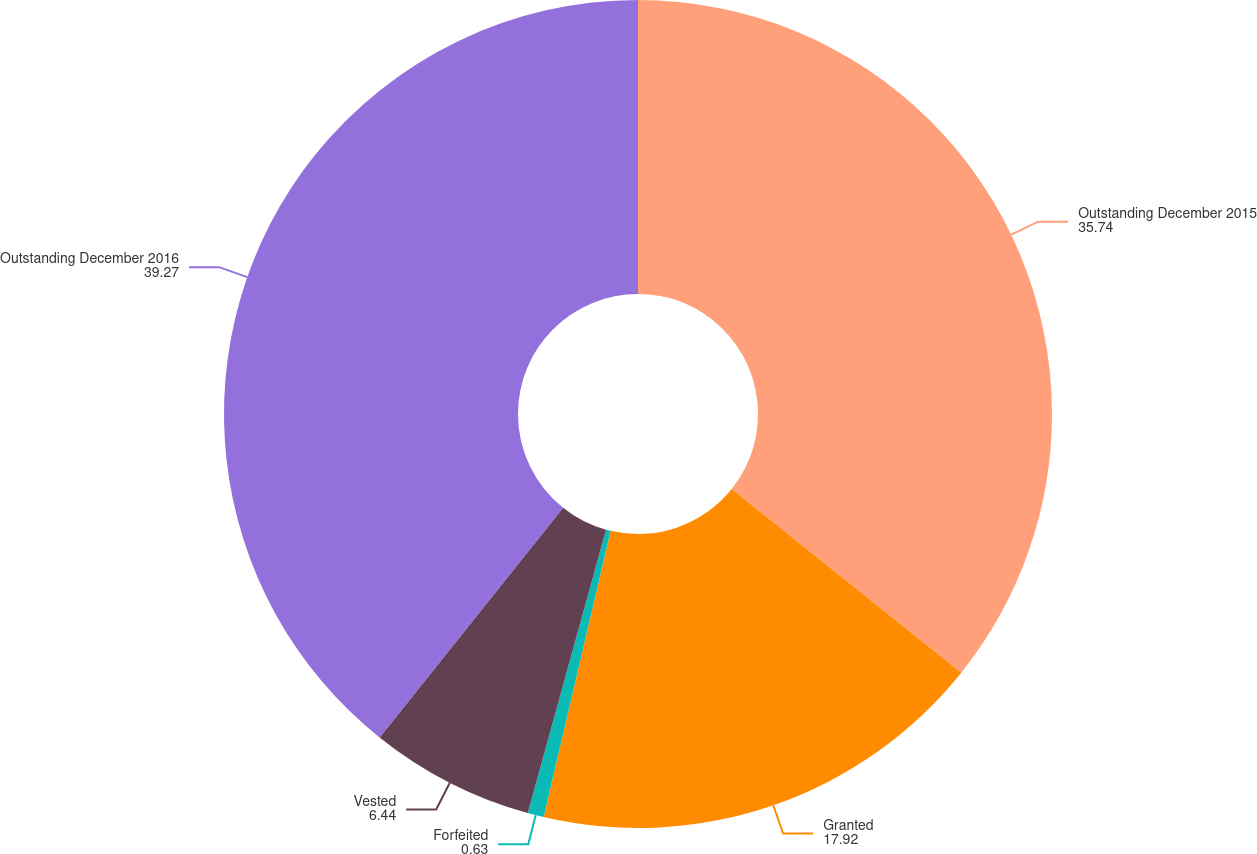<chart> <loc_0><loc_0><loc_500><loc_500><pie_chart><fcel>Outstanding December 2015<fcel>Granted<fcel>Forfeited<fcel>Vested<fcel>Outstanding December 2016<nl><fcel>35.74%<fcel>17.92%<fcel>0.63%<fcel>6.44%<fcel>39.27%<nl></chart> 